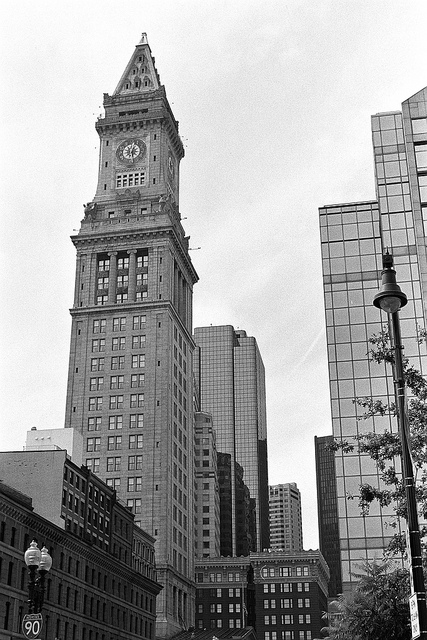<image>Where is the famous landmark in the picture? I am not sure about the famous landmark in the picture. It could be in Chicago, London, New York, or might be Big Ben. Where is the famous landmark in the picture? I am not sure where the famous landmark in the picture is. It can be seen in Chicago, London, New York, or somewhere else. 